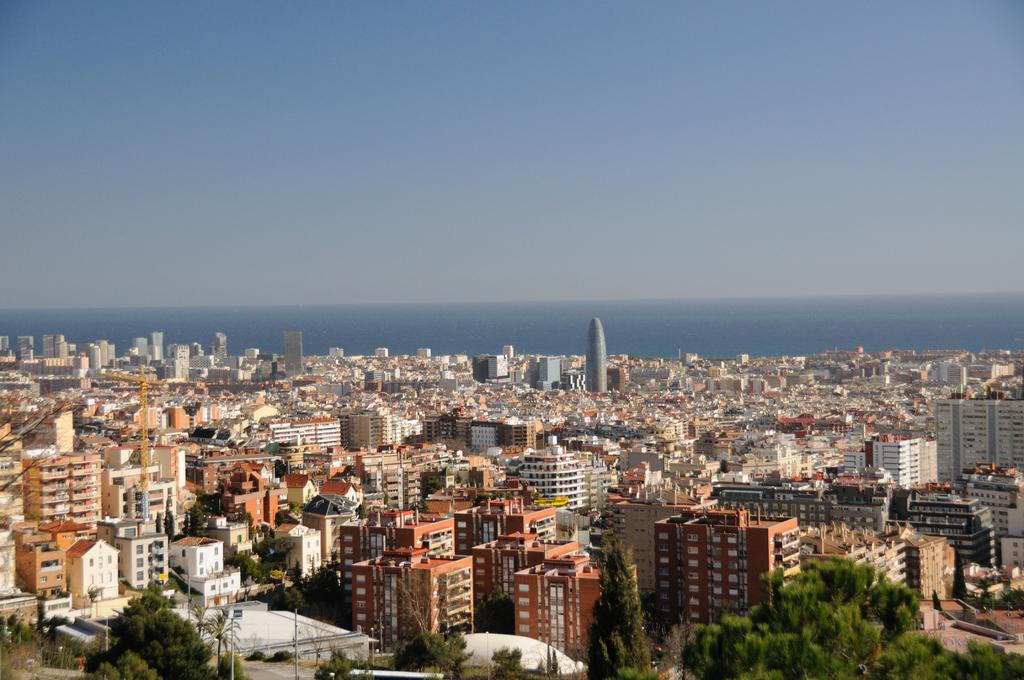What type of structures are visible in the image? There are many buildings with windows in the image. What can be seen in front of the buildings? There are many trees in front of the buildings. What is visible in the background of the image? Water, clouds, and the sky are visible in the background of the image. What type of discussion is taking place in the image? There is no discussion taking place in the image; it is a still image of buildings, trees, and the background. 